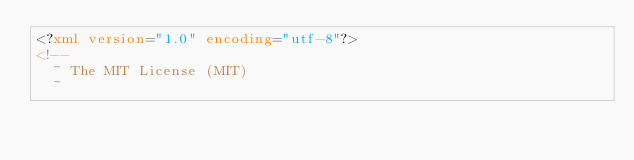<code> <loc_0><loc_0><loc_500><loc_500><_XML_><?xml version="1.0" encoding="utf-8"?>
<!--
  ~ The MIT License (MIT)
  ~</code> 